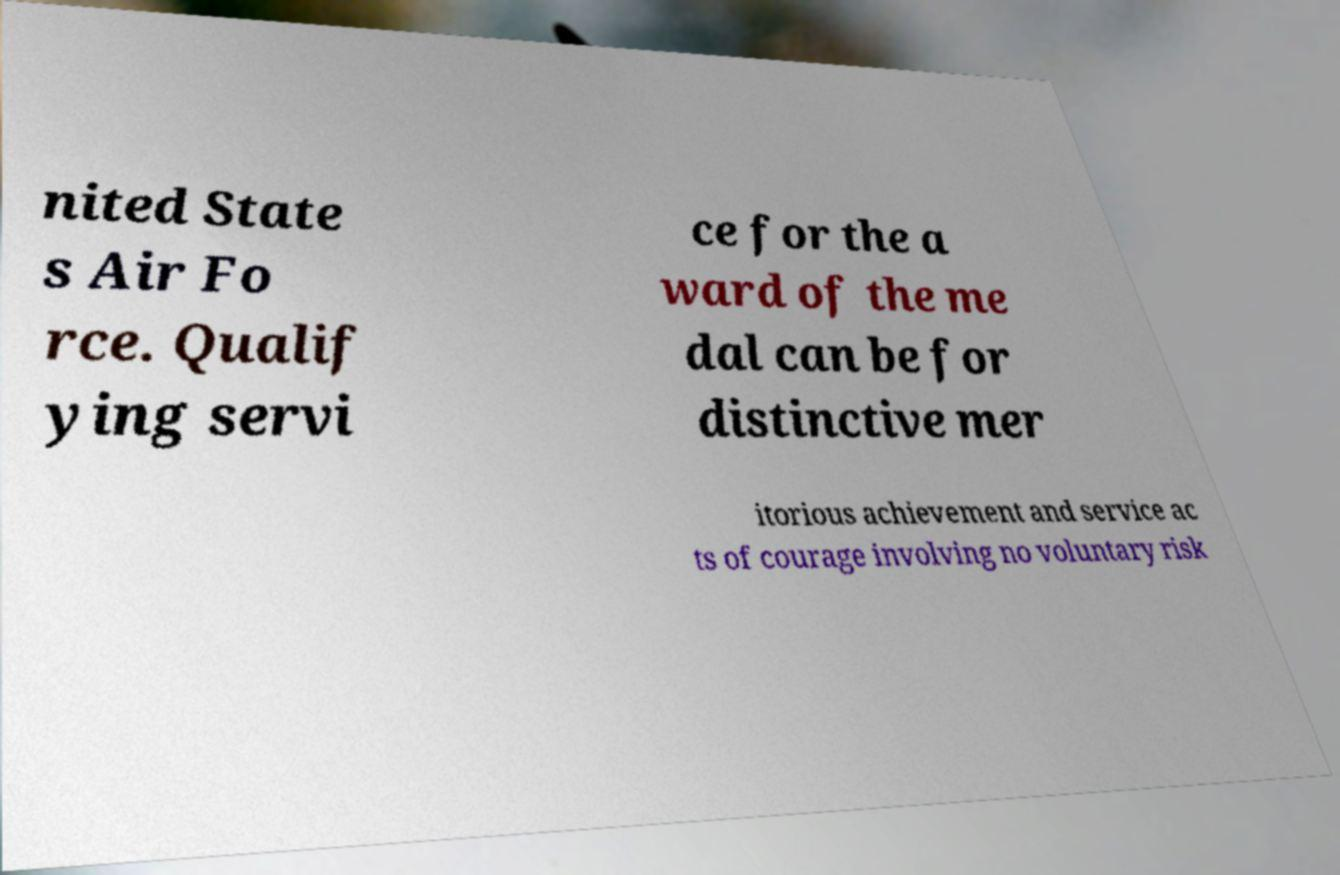Please identify and transcribe the text found in this image. nited State s Air Fo rce. Qualif ying servi ce for the a ward of the me dal can be for distinctive mer itorious achievement and service ac ts of courage involving no voluntary risk 